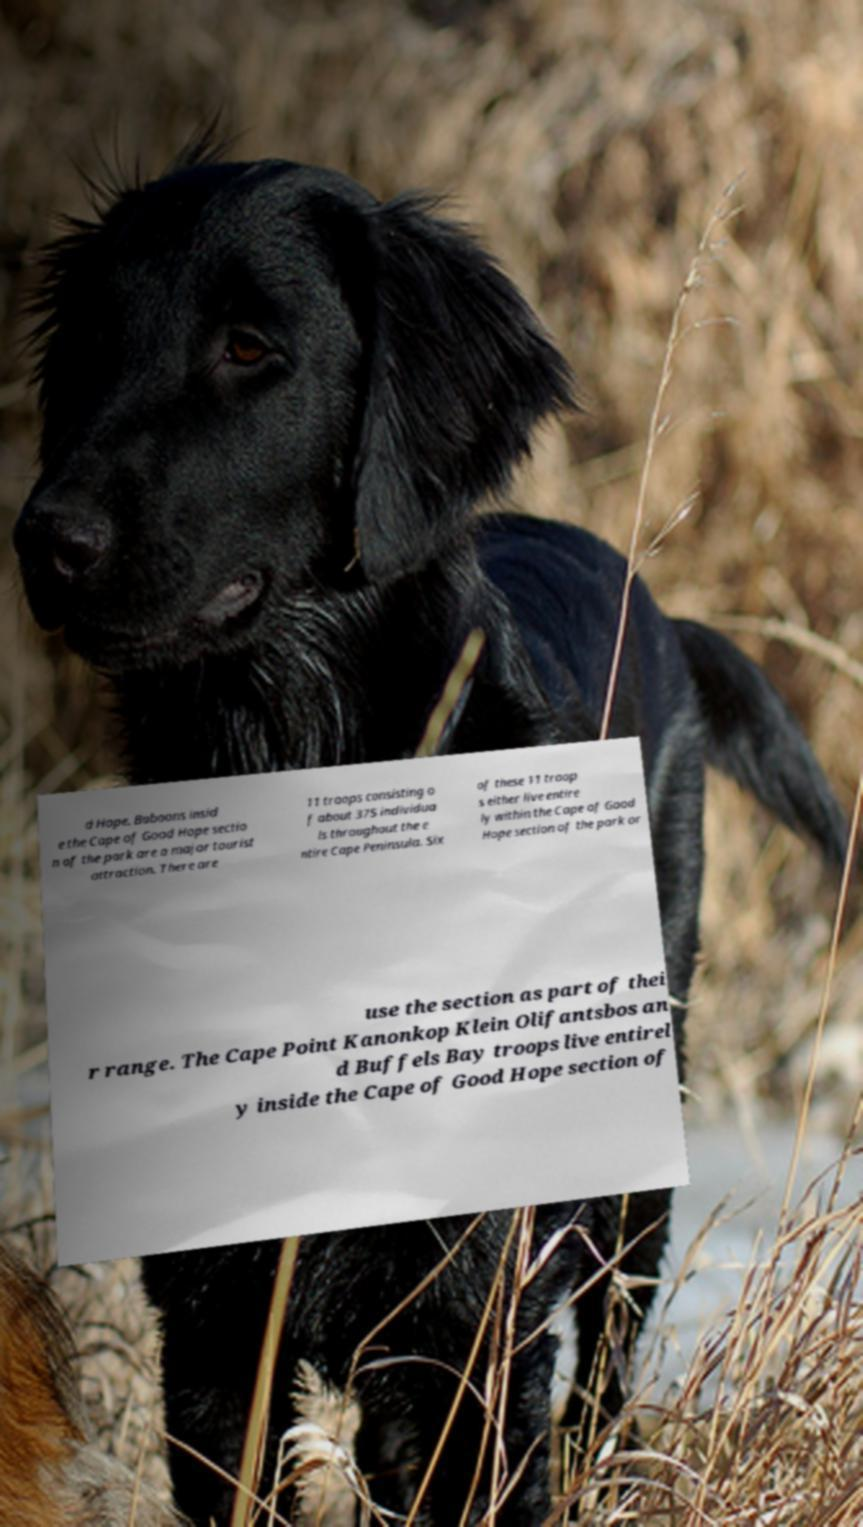What messages or text are displayed in this image? I need them in a readable, typed format. d Hope. Baboons insid e the Cape of Good Hope sectio n of the park are a major tourist attraction. There are 11 troops consisting o f about 375 individua ls throughout the e ntire Cape Peninsula. Six of these 11 troop s either live entire ly within the Cape of Good Hope section of the park or use the section as part of thei r range. The Cape Point Kanonkop Klein Olifantsbos an d Buffels Bay troops live entirel y inside the Cape of Good Hope section of 